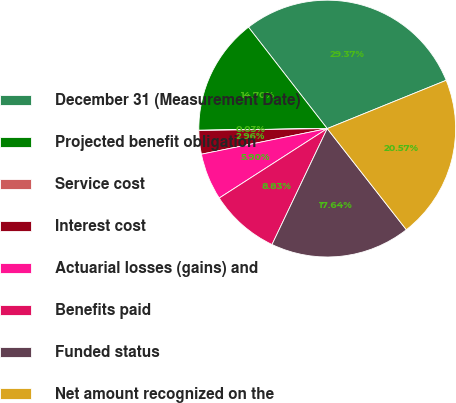<chart> <loc_0><loc_0><loc_500><loc_500><pie_chart><fcel>December 31 (Measurement Date)<fcel>Projected benefit obligation<fcel>Service cost<fcel>Interest cost<fcel>Actuarial losses (gains) and<fcel>Benefits paid<fcel>Funded status<fcel>Net amount recognized on the<nl><fcel>29.37%<fcel>14.7%<fcel>0.03%<fcel>2.96%<fcel>5.9%<fcel>8.83%<fcel>17.64%<fcel>20.57%<nl></chart> 